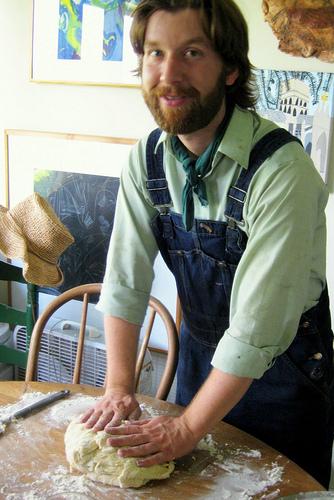What do you call the denim garment he is wearing?
Answer briefly. Overalls. Who is baking bread?
Concise answer only. Man. What is the man pressing?
Write a very short answer. Dough. What year was this photo taken?
Keep it brief. 2014. 